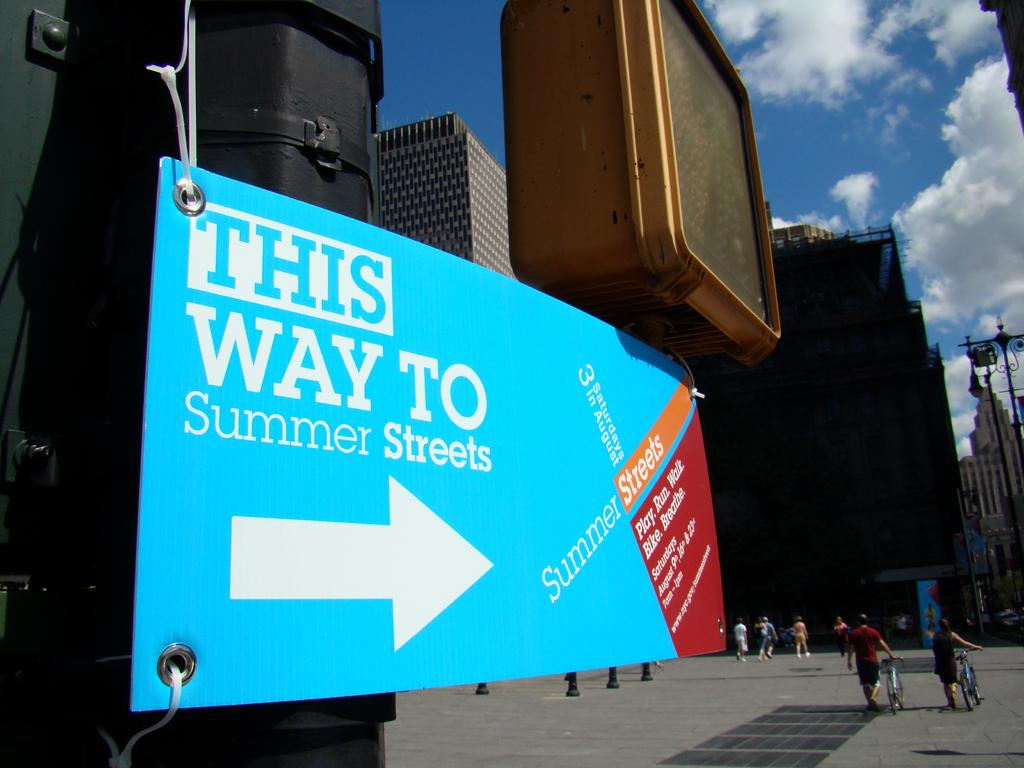Provide a one-sentence caption for the provided image. A sign in the sity saying "This way to summer streets". 